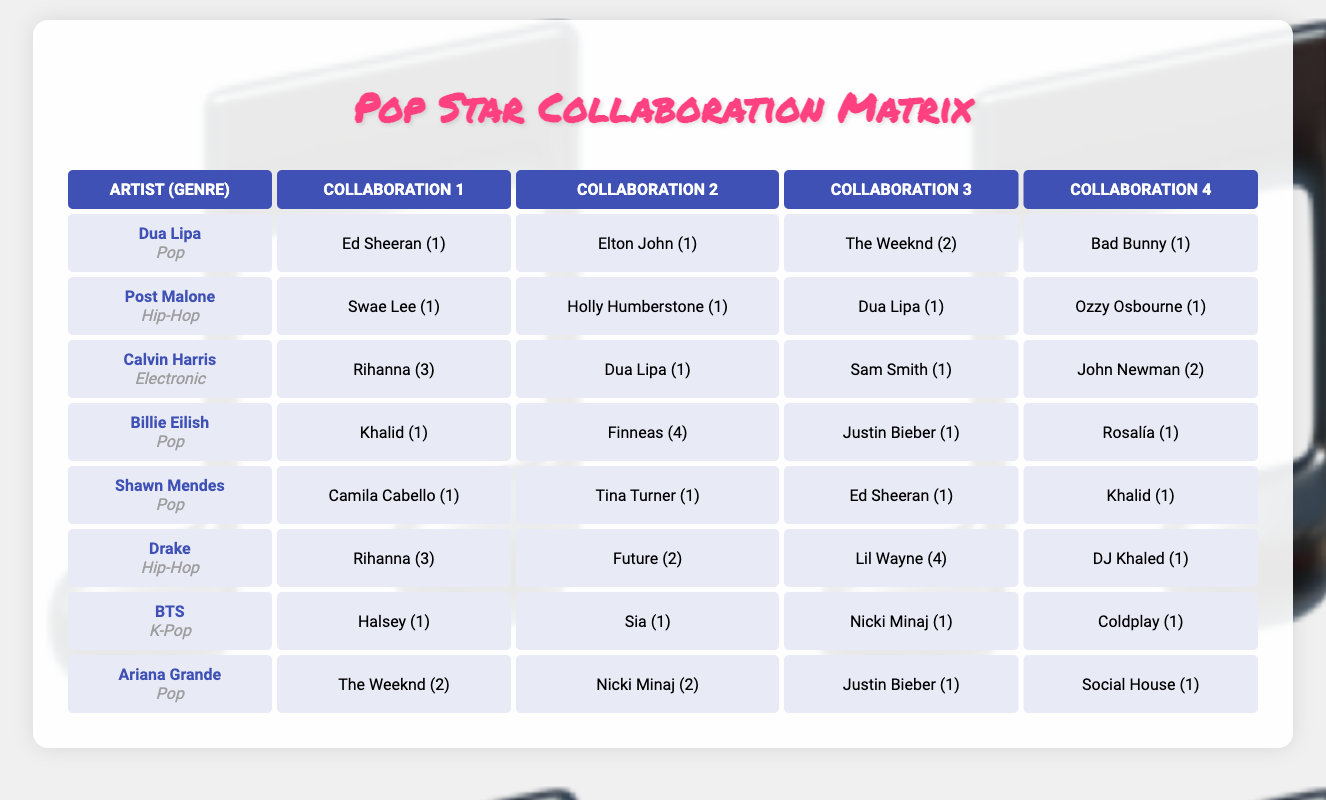What is the total number of collaborations for Billie Eilish? Billie Eilish has collaborations listed with four artists. The breakdown is: Khalid (1), Finneas (4), Justin Bieber (1), and Rosalía (1). Adding these gives us a total of 1 + 4 + 1 + 1 = 7 collaborations.
Answer: 7 Who collaborated with Drake the most? Drake's collaboration counts are as follows: Rihanna (3), Future (2), Lil Wayne (4), and DJ Khaled (1). The highest count is Lil Wayne with 4 collaborations.
Answer: Lil Wayne True or False: Dua Lipa has more collaborations than Ariana Grande. Dua Lipa has collaboration counts of: Ed Sheeran (1), Elton John (1), The Weeknd (2), and Bad Bunny (1). Total = 1 + 1 + 2 + 1 = 5 collaborations. Ariana Grande's counts are: The Weeknd (2), Nicki Minaj (2), Justin Bieber (1), and Social House (1). Total = 2 + 2 + 1 + 1 = 6 collaborations. Since 5 is less than 6, the statement is false.
Answer: False What is the average number of collaborations for artists in the Pop genre? In the Pop genre, the artists and their collaborations are: Dua Lipa (5), Billie Eilish (7), Shawn Mendes (4), and Ariana Grande (6). Adding these gives 5 + 7 + 4 + 6 = 22 collaborations. There are 4 artists, so the average is 22 / 4 = 5.5.
Answer: 5.5 How many artists collaborated with Calvin Harris? Calvin Harris collaborated with four artists: Rihanna (3), Dua Lipa (1), Sam Smith (1), and John Newman (2). Count of artists yields 4.
Answer: 4 Which genre has the highest single collaboration count for a collaboration? Reviewing the table, the highest single collaboration counts are found as follows: Rihanna (3) with Calvin Harris and Drake, and Lil Wayne (4) with Drake. Since Lil Wayne's count of 4 is greater than 3, the highest single collaboration count is with Drake.
Answer: Hip-Hop How many collaborations did BTS have with non-English speaking artists? BTS collaborated with four artists: Halsey (1), Sia (1), Nicki Minaj (1), and Coldplay (1). Out of these, Sia is the only artist known for non-English speaking songs primarily, as she sings in both English and her native tongue. So there is only 1 noted collaboration with a non-English speaking artist.
Answer: 1 If we combine the collaborations of Hip-Hop artists, what is the total? For Hip-Hop: Post Malone's total is 4 (1 + 1 + 1 + 1), and Drake's total is 11 (3 + 2 + 4 + 1). Combining these, we have a total of 4 + 11 = 15 collaborations in the Hip-Hop genre.
Answer: 15 